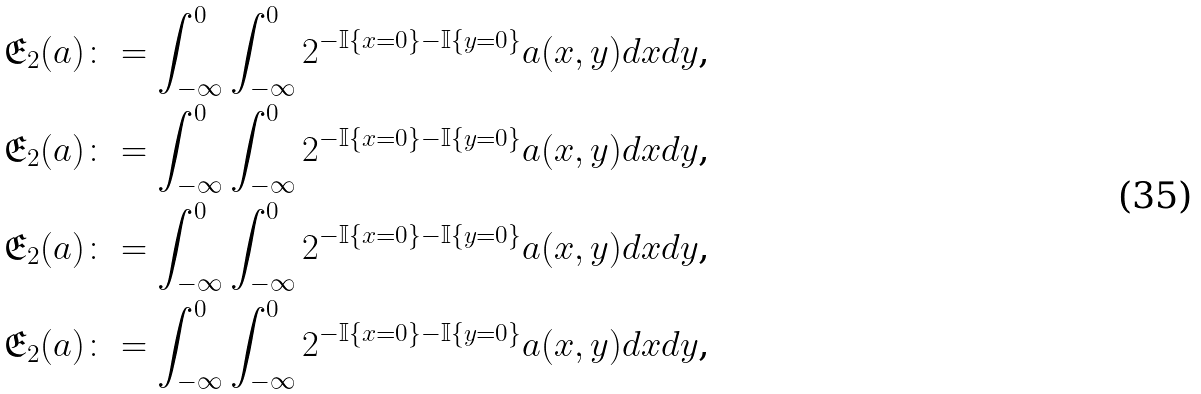<formula> <loc_0><loc_0><loc_500><loc_500>\mathfrak { E } _ { 2 } ( a ) & \colon = \int _ { - \infty } ^ { 0 } \int _ { - \infty } ^ { 0 } 2 ^ { - \mathbb { I } \{ x = 0 \} - \mathbb { I } \{ y = 0 \} } a ( x , y ) d x d y \text {,} \\ \mathfrak { E } _ { 2 } ( a ) & \colon = \int _ { - \infty } ^ { 0 } \int _ { - \infty } ^ { 0 } 2 ^ { - \mathbb { I } \{ x = 0 \} - \mathbb { I } \{ y = 0 \} } a ( x , y ) d x d y \text {,} \\ \mathfrak { E } _ { 2 } ( a ) & \colon = \int _ { - \infty } ^ { 0 } \int _ { - \infty } ^ { 0 } 2 ^ { - \mathbb { I } \{ x = 0 \} - \mathbb { I } \{ y = 0 \} } a ( x , y ) d x d y \text {,} \\ \mathfrak { E } _ { 2 } ( a ) & \colon = \int _ { - \infty } ^ { 0 } \int _ { - \infty } ^ { 0 } 2 ^ { - \mathbb { I } \{ x = 0 \} - \mathbb { I } \{ y = 0 \} } a ( x , y ) d x d y \text {,}</formula> 